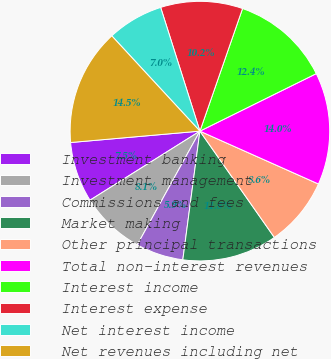<chart> <loc_0><loc_0><loc_500><loc_500><pie_chart><fcel>Investment banking<fcel>Investment management<fcel>Commissions and fees<fcel>Market making<fcel>Other principal transactions<fcel>Total non-interest revenues<fcel>Interest income<fcel>Interest expense<fcel>Net interest income<fcel>Net revenues including net<nl><fcel>7.53%<fcel>8.06%<fcel>5.91%<fcel>11.83%<fcel>8.6%<fcel>13.98%<fcel>12.37%<fcel>10.22%<fcel>6.99%<fcel>14.52%<nl></chart> 